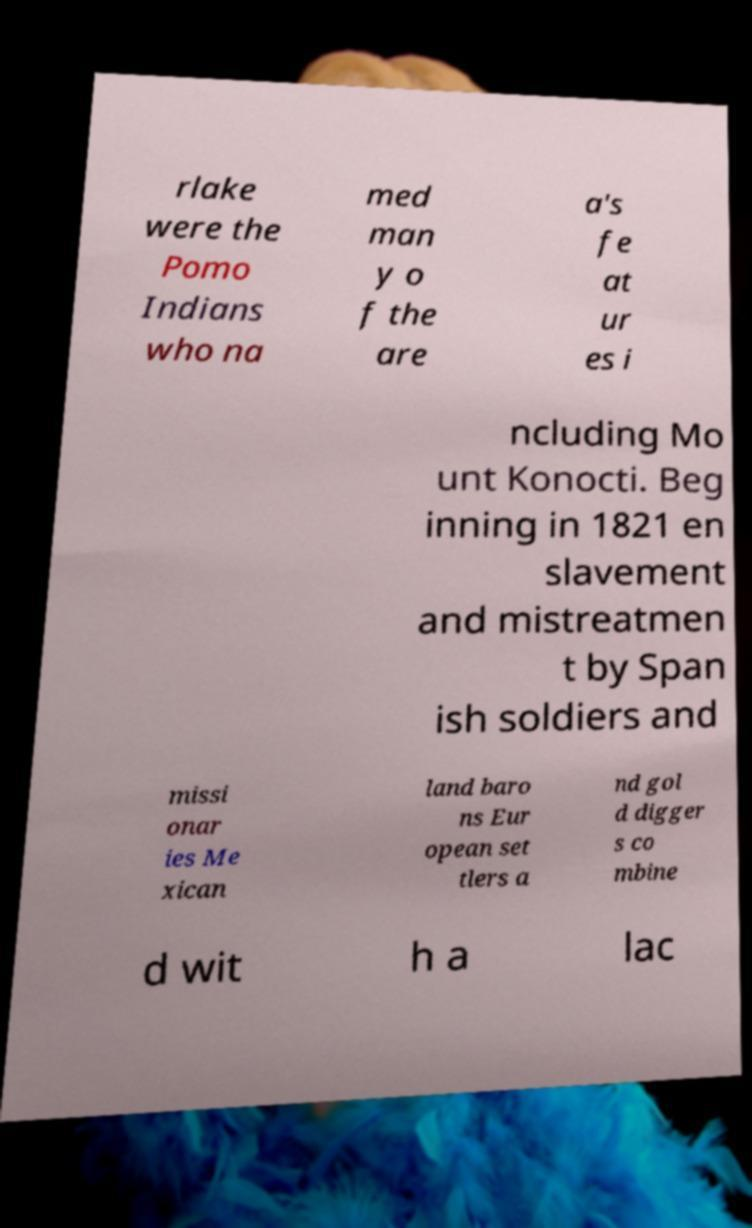Can you accurately transcribe the text from the provided image for me? rlake were the Pomo Indians who na med man y o f the are a's fe at ur es i ncluding Mo unt Konocti. Beg inning in 1821 en slavement and mistreatmen t by Span ish soldiers and missi onar ies Me xican land baro ns Eur opean set tlers a nd gol d digger s co mbine d wit h a lac 